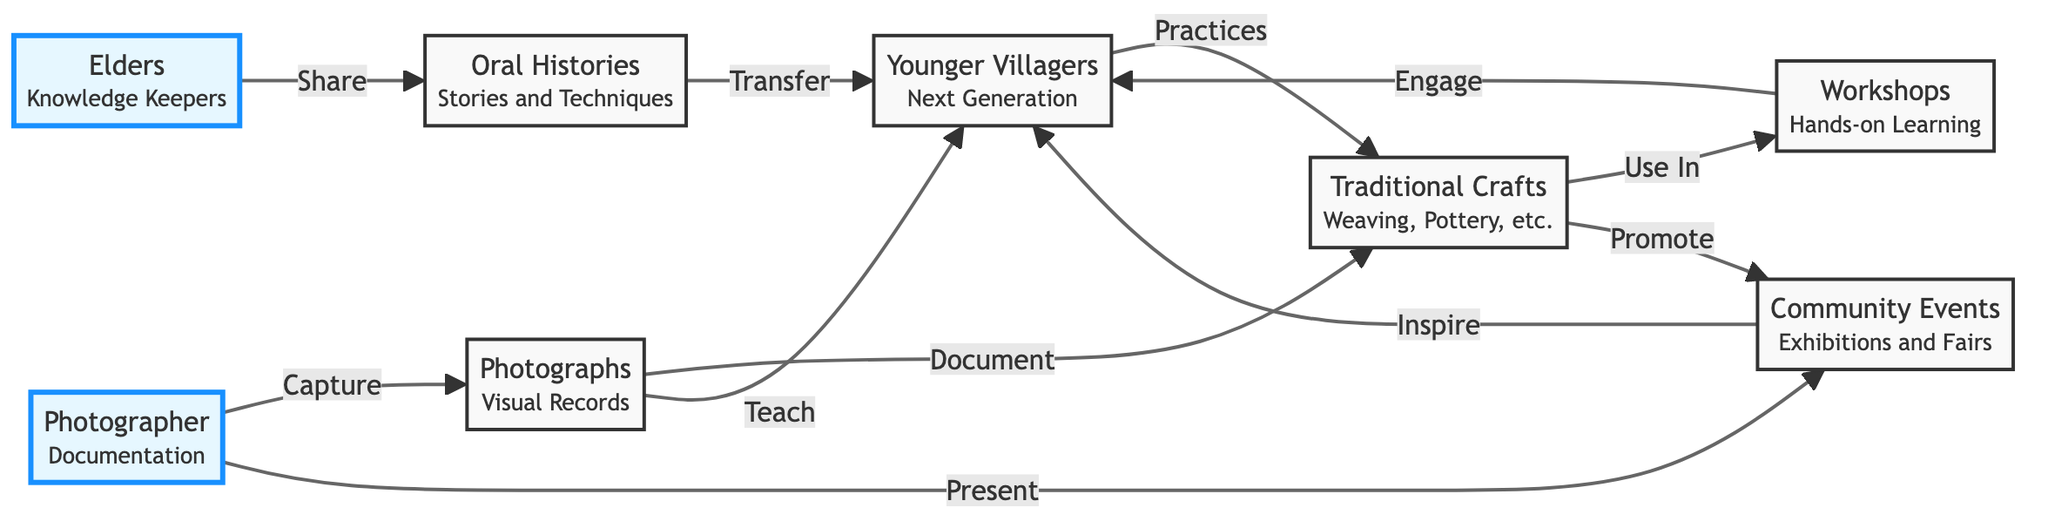What is the first node in the flowchart? The first node in the flowchart is labeled "Elders" and serves as the starting point for the knowledge transfer process. It represents the elders as the knowledge keepers.
Answer: Elders How many connections does the "Photographer" node have? The "Photographer" node has three connections: one to "Photographs", one to "Community Events", and one to "Younger Villagers". This indicates their role in documentation and engagement.
Answer: 3 Which node directly receives knowledge from the "Elders"? The "Younger Villagers" node receives knowledge directly from the "Elders" through oral histories shared by them. This indicates a direct transfer process between these two nodes.
Answer: Younger Villagers What type of traditional crafts are mentioned in the flowchart? The flowchart mentions "Weaving" and "Pottery" as examples of traditional crafts that are practiced by the younger villagers after receiving knowledge.
Answer: Weaving, Pottery Which node promotes community involvement through exhibitions? The "Community Events" node promotes community involvement through exhibitions and fairs, which aims to educate and inspire younger villagers about traditional crafts.
Answer: Community Events What is the relationship between "Photographs" and "Traditional Crafts"? The relationship is that "Photographs" document "Traditional Crafts", capturing their essence and preserving their techniques visually for future generations.
Answer: Document How does the "Younger Villagers" node engage with traditional crafts? The "Younger Villagers" engage with traditional crafts by participating in workshops, which provide hands-on learning experiences that are essential for skill development.
Answer: Workshops Which node provides a hands-on learning experience? The "Workshops" node provides a hands-on learning experience for the younger villagers, allowing them to practice their skills directly.
Answer: Workshops What is the result of the "Photographer" capturing images? The result is "Visual Records," which serve as documentation of the traditional crafts and the process, helping in preservation for the future.
Answer: Visual Records 